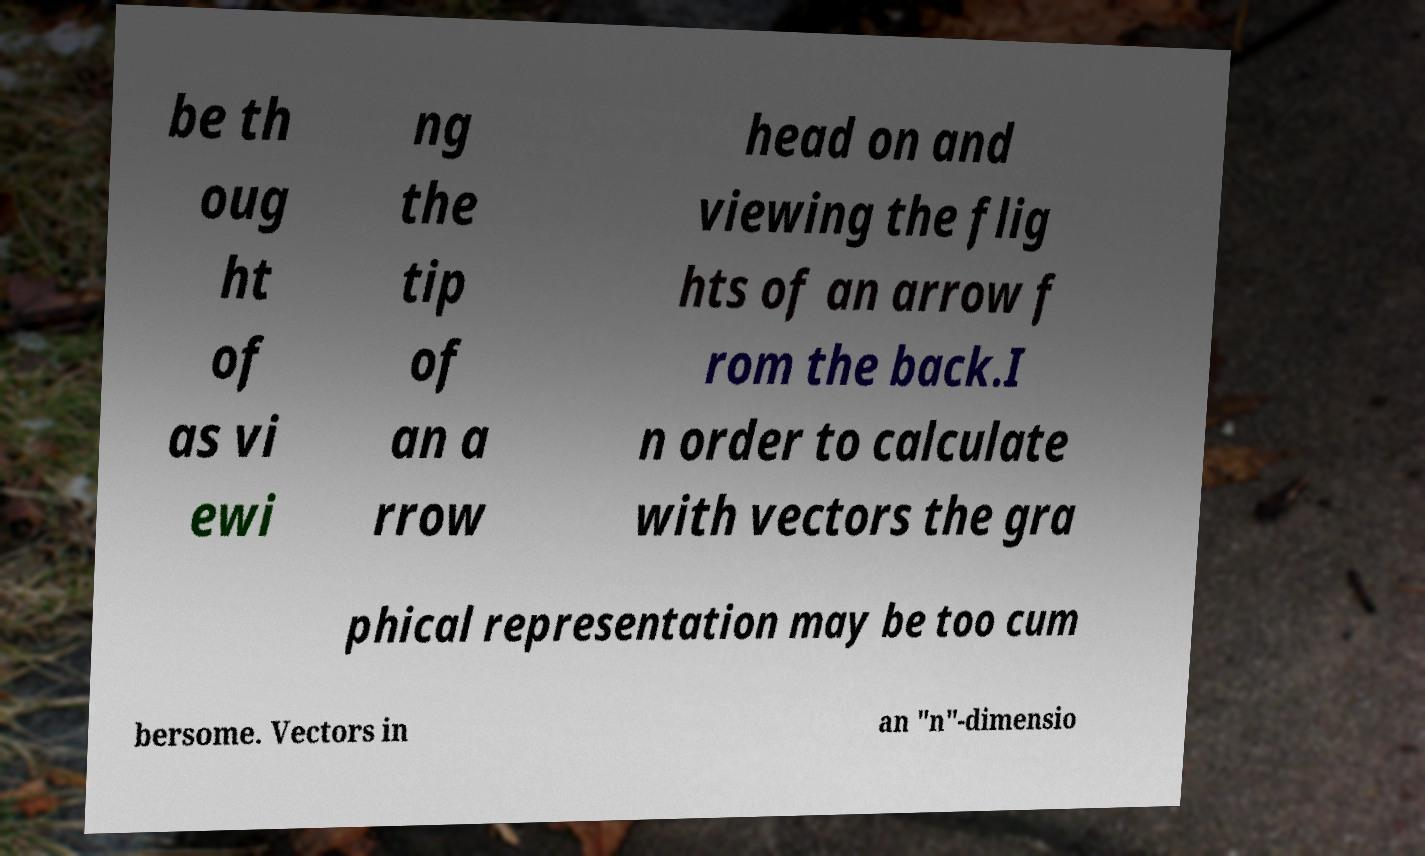Could you assist in decoding the text presented in this image and type it out clearly? be th oug ht of as vi ewi ng the tip of an a rrow head on and viewing the flig hts of an arrow f rom the back.I n order to calculate with vectors the gra phical representation may be too cum bersome. Vectors in an "n"-dimensio 